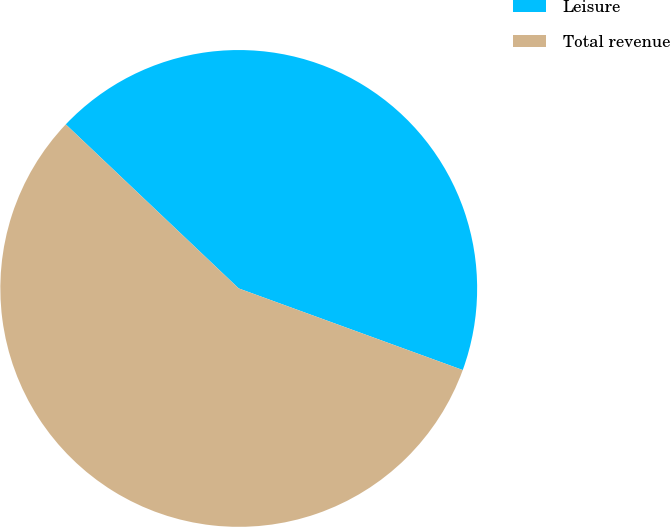Convert chart to OTSL. <chart><loc_0><loc_0><loc_500><loc_500><pie_chart><fcel>Leisure<fcel>Total revenue<nl><fcel>43.48%<fcel>56.52%<nl></chart> 